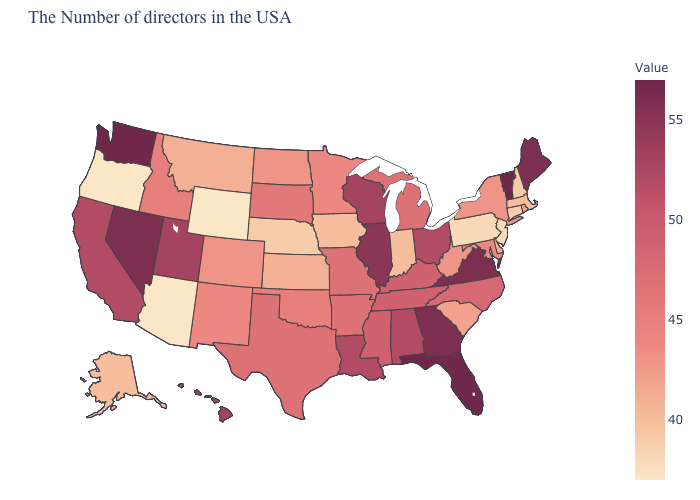Which states have the highest value in the USA?
Concise answer only. Vermont, Florida, Washington. Is the legend a continuous bar?
Keep it brief. Yes. Among the states that border Alabama , does Florida have the lowest value?
Concise answer only. No. Among the states that border Nevada , which have the highest value?
Concise answer only. Utah. Does South Carolina have the highest value in the USA?
Answer briefly. No. Does the map have missing data?
Short answer required. No. Does the map have missing data?
Short answer required. No. Which states hav the highest value in the MidWest?
Give a very brief answer. Illinois. 